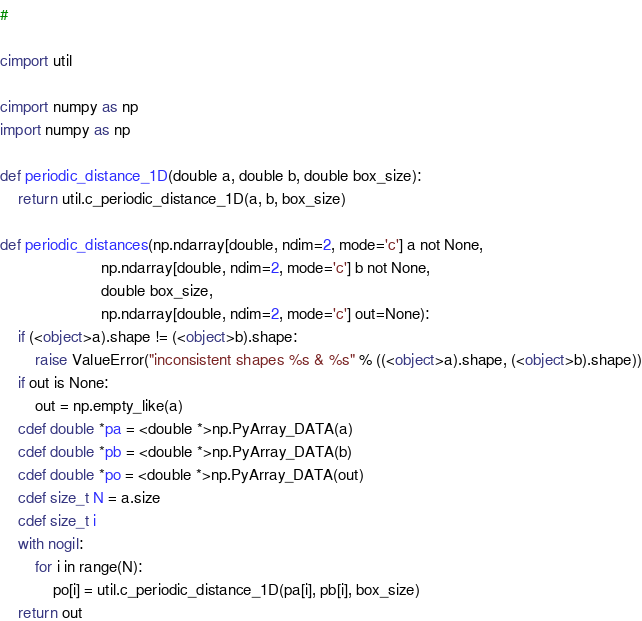Convert code to text. <code><loc_0><loc_0><loc_500><loc_500><_Cython_>#

cimport util

cimport numpy as np
import numpy as np

def periodic_distance_1D(double a, double b, double box_size):
    return util.c_periodic_distance_1D(a, b, box_size)

def periodic_distances(np.ndarray[double, ndim=2, mode='c'] a not None,
                       np.ndarray[double, ndim=2, mode='c'] b not None,
                       double box_size,
                       np.ndarray[double, ndim=2, mode='c'] out=None):
    if (<object>a).shape != (<object>b).shape:
        raise ValueError("inconsistent shapes %s & %s" % ((<object>a).shape, (<object>b).shape))
    if out is None:
        out = np.empty_like(a)
    cdef double *pa = <double *>np.PyArray_DATA(a)
    cdef double *pb = <double *>np.PyArray_DATA(b)
    cdef double *po = <double *>np.PyArray_DATA(out)
    cdef size_t N = a.size
    cdef size_t i
    with nogil:
        for i in range(N):
            po[i] = util.c_periodic_distance_1D(pa[i], pb[i], box_size)
    return out
</code> 